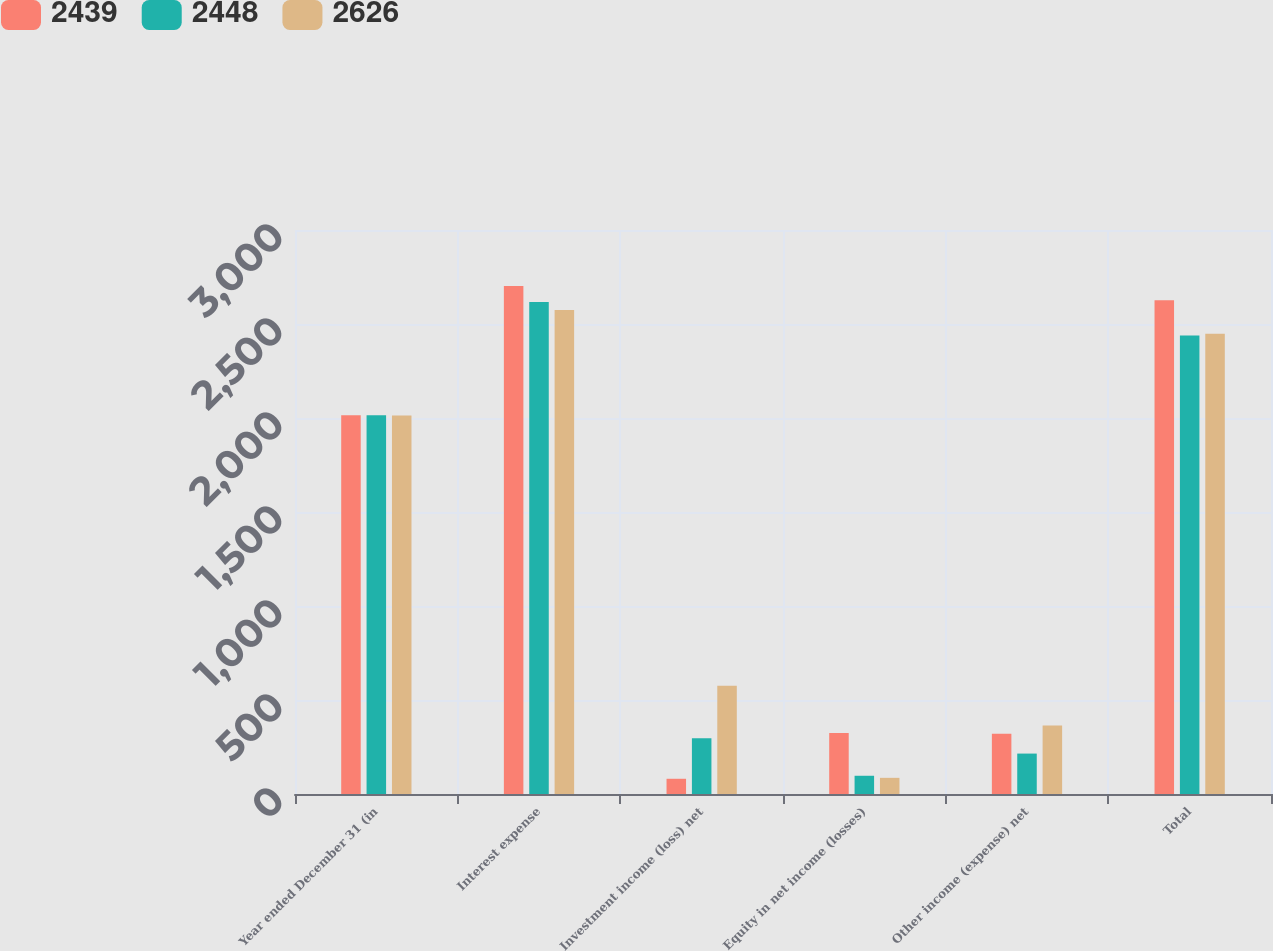Convert chart. <chart><loc_0><loc_0><loc_500><loc_500><stacked_bar_chart><ecel><fcel>Year ended December 31 (in<fcel>Interest expense<fcel>Investment income (loss) net<fcel>Equity in net income (losses)<fcel>Other income (expense) net<fcel>Total<nl><fcel>2439<fcel>2015<fcel>2702<fcel>81<fcel>325<fcel>320<fcel>2626<nl><fcel>2448<fcel>2014<fcel>2617<fcel>296<fcel>97<fcel>215<fcel>2439<nl><fcel>2626<fcel>2013<fcel>2574<fcel>576<fcel>86<fcel>364<fcel>2448<nl></chart> 